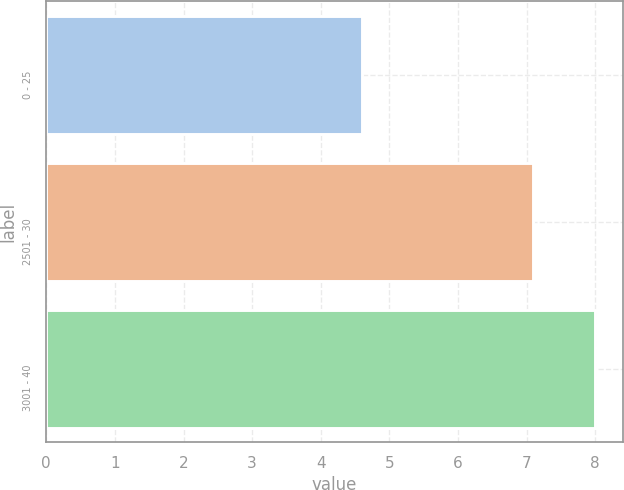<chart> <loc_0><loc_0><loc_500><loc_500><bar_chart><fcel>0 - 25<fcel>2501 - 30<fcel>3001 - 40<nl><fcel>4.6<fcel>7.1<fcel>8<nl></chart> 